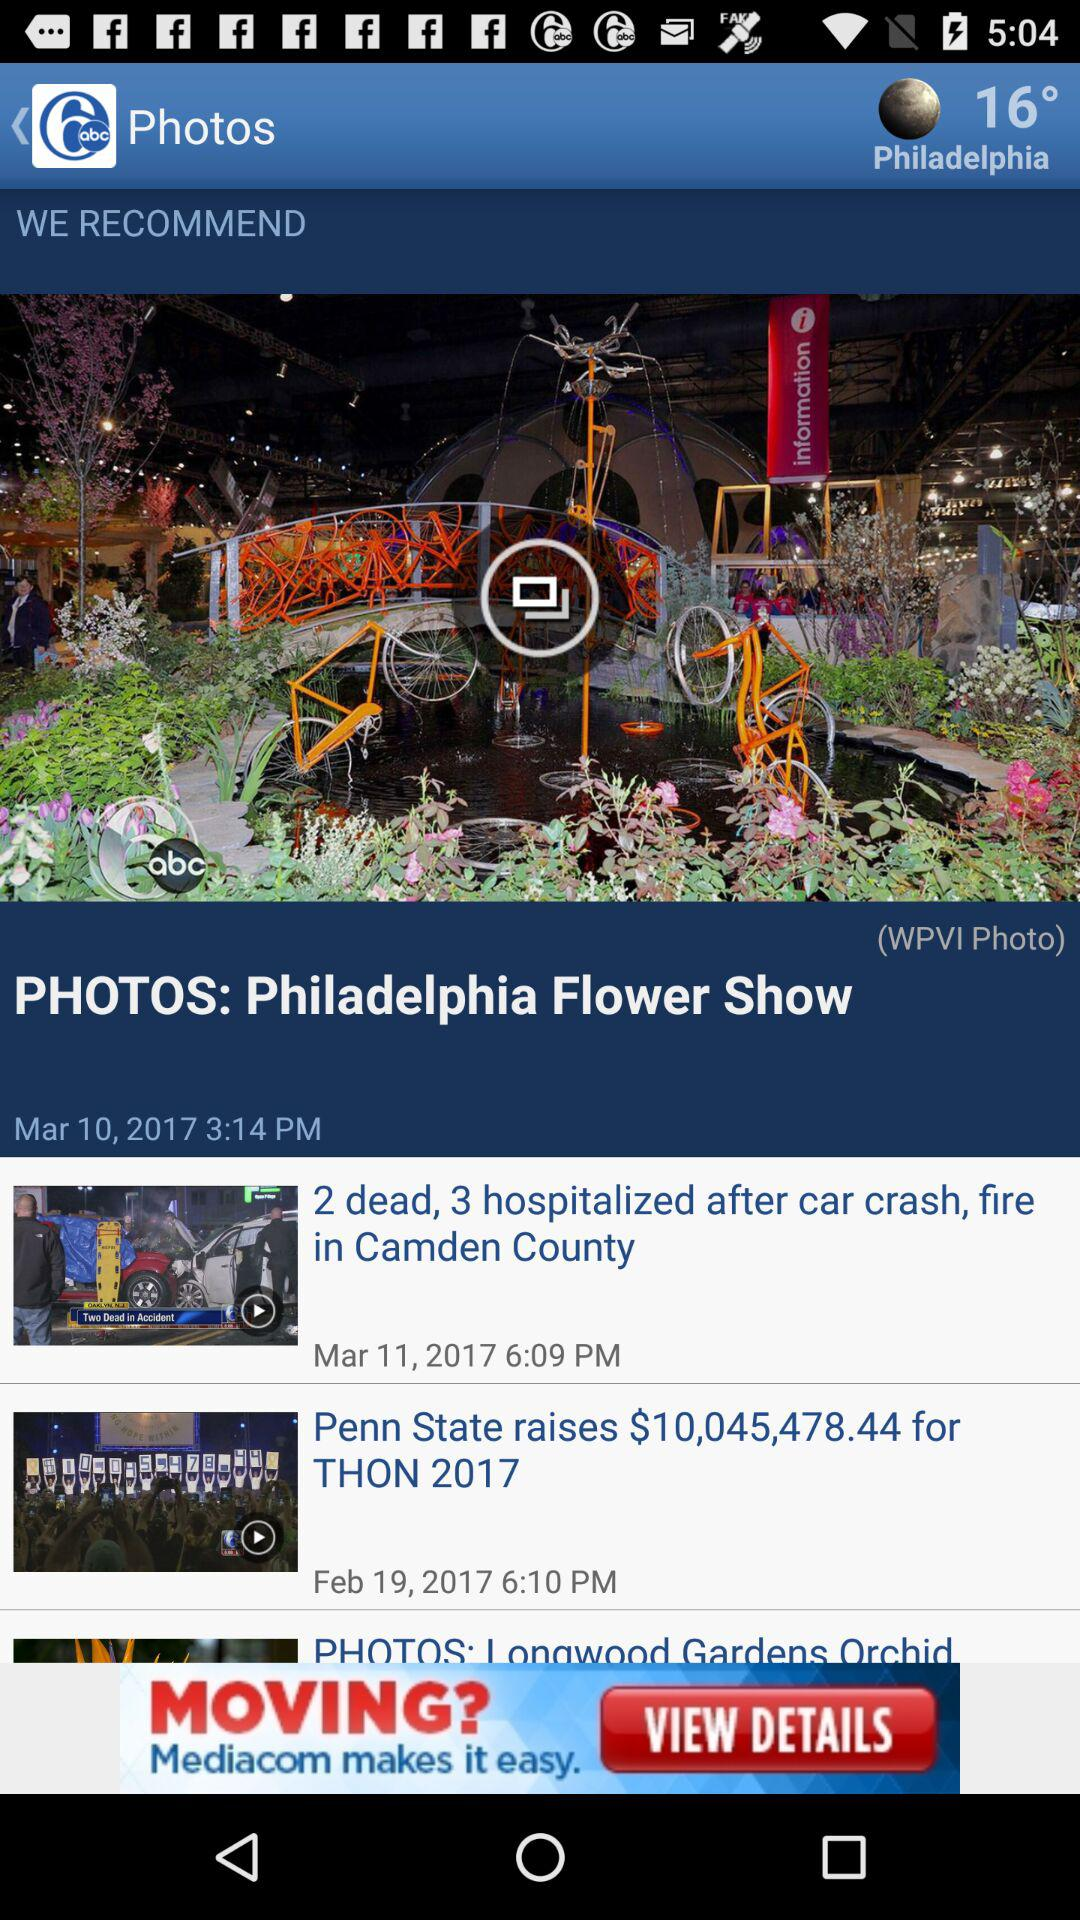What is the temperature? The temperature is 16°. 